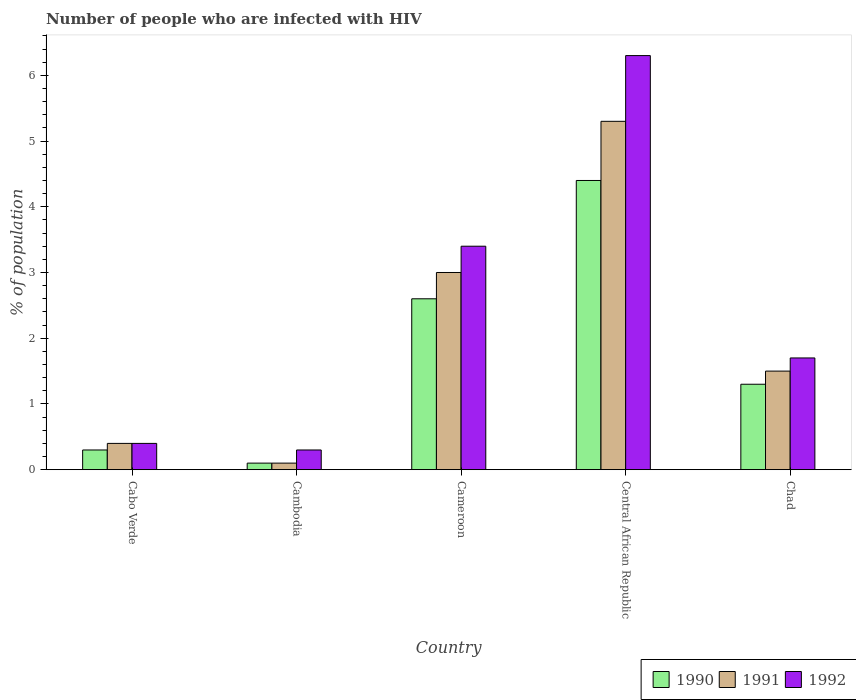How many different coloured bars are there?
Ensure brevity in your answer.  3. How many groups of bars are there?
Your answer should be very brief. 5. Are the number of bars per tick equal to the number of legend labels?
Make the answer very short. Yes. How many bars are there on the 1st tick from the right?
Offer a terse response. 3. What is the label of the 1st group of bars from the left?
Ensure brevity in your answer.  Cabo Verde. What is the percentage of HIV infected population in in 1991 in Cabo Verde?
Offer a terse response. 0.4. Across all countries, what is the maximum percentage of HIV infected population in in 1990?
Offer a very short reply. 4.4. In which country was the percentage of HIV infected population in in 1992 maximum?
Offer a terse response. Central African Republic. In which country was the percentage of HIV infected population in in 1992 minimum?
Your response must be concise. Cambodia. What is the total percentage of HIV infected population in in 1992 in the graph?
Provide a succinct answer. 12.1. What is the difference between the percentage of HIV infected population in in 1990 in Central African Republic and that in Chad?
Ensure brevity in your answer.  3.1. What is the difference between the percentage of HIV infected population in in 1992 in Cameroon and the percentage of HIV infected population in in 1991 in Cabo Verde?
Your answer should be compact. 3. What is the average percentage of HIV infected population in in 1991 per country?
Provide a short and direct response. 2.06. What is the difference between the percentage of HIV infected population in of/in 1992 and percentage of HIV infected population in of/in 1990 in Cambodia?
Your answer should be very brief. 0.2. In how many countries, is the percentage of HIV infected population in in 1991 greater than 2.6 %?
Your answer should be compact. 2. What is the ratio of the percentage of HIV infected population in in 1991 in Cameroon to that in Central African Republic?
Offer a terse response. 0.57. Is the percentage of HIV infected population in in 1990 in Cabo Verde less than that in Cambodia?
Offer a very short reply. No. Is the difference between the percentage of HIV infected population in in 1992 in Cambodia and Central African Republic greater than the difference between the percentage of HIV infected population in in 1990 in Cambodia and Central African Republic?
Keep it short and to the point. No. What is the difference between the highest and the second highest percentage of HIV infected population in in 1990?
Offer a very short reply. -1.3. What is the difference between the highest and the lowest percentage of HIV infected population in in 1990?
Ensure brevity in your answer.  4.3. In how many countries, is the percentage of HIV infected population in in 1992 greater than the average percentage of HIV infected population in in 1992 taken over all countries?
Offer a very short reply. 2. Is the sum of the percentage of HIV infected population in in 1992 in Cameroon and Central African Republic greater than the maximum percentage of HIV infected population in in 1991 across all countries?
Offer a terse response. Yes. What does the 1st bar from the left in Chad represents?
Keep it short and to the point. 1990. How many bars are there?
Offer a terse response. 15. What is the difference between two consecutive major ticks on the Y-axis?
Keep it short and to the point. 1. Does the graph contain any zero values?
Offer a terse response. No. How are the legend labels stacked?
Provide a short and direct response. Horizontal. What is the title of the graph?
Provide a short and direct response. Number of people who are infected with HIV. What is the label or title of the Y-axis?
Offer a very short reply. % of population. What is the % of population of 1992 in Cambodia?
Make the answer very short. 0.3. What is the % of population of 1990 in Cameroon?
Your answer should be compact. 2.6. What is the % of population in 1992 in Cameroon?
Provide a succinct answer. 3.4. What is the % of population of 1990 in Central African Republic?
Provide a short and direct response. 4.4. What is the % of population in 1992 in Central African Republic?
Give a very brief answer. 6.3. What is the % of population in 1990 in Chad?
Provide a short and direct response. 1.3. What is the % of population of 1991 in Chad?
Provide a short and direct response. 1.5. What is the % of population in 1992 in Chad?
Provide a short and direct response. 1.7. Across all countries, what is the maximum % of population in 1991?
Offer a very short reply. 5.3. Across all countries, what is the maximum % of population in 1992?
Make the answer very short. 6.3. Across all countries, what is the minimum % of population in 1990?
Provide a succinct answer. 0.1. Across all countries, what is the minimum % of population of 1991?
Offer a terse response. 0.1. What is the total % of population of 1990 in the graph?
Your answer should be very brief. 8.7. What is the total % of population in 1992 in the graph?
Your answer should be compact. 12.1. What is the difference between the % of population of 1991 in Cabo Verde and that in Cambodia?
Keep it short and to the point. 0.3. What is the difference between the % of population of 1992 in Cabo Verde and that in Cambodia?
Keep it short and to the point. 0.1. What is the difference between the % of population of 1990 in Cabo Verde and that in Central African Republic?
Keep it short and to the point. -4.1. What is the difference between the % of population of 1990 in Cambodia and that in Cameroon?
Your response must be concise. -2.5. What is the difference between the % of population of 1991 in Cambodia and that in Central African Republic?
Your answer should be compact. -5.2. What is the difference between the % of population of 1990 in Cambodia and that in Chad?
Your answer should be compact. -1.2. What is the difference between the % of population of 1991 in Cambodia and that in Chad?
Keep it short and to the point. -1.4. What is the difference between the % of population of 1992 in Cambodia and that in Chad?
Offer a terse response. -1.4. What is the difference between the % of population in 1990 in Cameroon and that in Chad?
Give a very brief answer. 1.3. What is the difference between the % of population in 1990 in Central African Republic and that in Chad?
Provide a short and direct response. 3.1. What is the difference between the % of population of 1991 in Central African Republic and that in Chad?
Your answer should be very brief. 3.8. What is the difference between the % of population in 1992 in Central African Republic and that in Chad?
Your answer should be very brief. 4.6. What is the difference between the % of population of 1990 in Cabo Verde and the % of population of 1991 in Cambodia?
Your answer should be compact. 0.2. What is the difference between the % of population in 1990 in Cabo Verde and the % of population in 1992 in Cambodia?
Make the answer very short. 0. What is the difference between the % of population in 1991 in Cabo Verde and the % of population in 1992 in Cambodia?
Your answer should be very brief. 0.1. What is the difference between the % of population in 1990 in Cabo Verde and the % of population in 1991 in Cameroon?
Provide a succinct answer. -2.7. What is the difference between the % of population of 1991 in Cabo Verde and the % of population of 1992 in Cameroon?
Offer a terse response. -3. What is the difference between the % of population of 1990 in Cabo Verde and the % of population of 1991 in Central African Republic?
Provide a succinct answer. -5. What is the difference between the % of population of 1990 in Cabo Verde and the % of population of 1992 in Central African Republic?
Your answer should be very brief. -6. What is the difference between the % of population of 1991 in Cabo Verde and the % of population of 1992 in Central African Republic?
Ensure brevity in your answer.  -5.9. What is the difference between the % of population in 1990 in Cabo Verde and the % of population in 1992 in Chad?
Your response must be concise. -1.4. What is the difference between the % of population of 1990 in Cambodia and the % of population of 1991 in Cameroon?
Your answer should be very brief. -2.9. What is the difference between the % of population in 1990 in Cambodia and the % of population in 1992 in Cameroon?
Ensure brevity in your answer.  -3.3. What is the difference between the % of population in 1990 in Cambodia and the % of population in 1992 in Central African Republic?
Make the answer very short. -6.2. What is the difference between the % of population in 1991 in Cambodia and the % of population in 1992 in Central African Republic?
Your answer should be compact. -6.2. What is the difference between the % of population of 1990 in Cambodia and the % of population of 1991 in Chad?
Give a very brief answer. -1.4. What is the difference between the % of population in 1990 in Cambodia and the % of population in 1992 in Chad?
Offer a terse response. -1.6. What is the difference between the % of population in 1991 in Cambodia and the % of population in 1992 in Chad?
Offer a terse response. -1.6. What is the difference between the % of population in 1990 in Cameroon and the % of population in 1991 in Chad?
Ensure brevity in your answer.  1.1. What is the difference between the % of population in 1990 in Cameroon and the % of population in 1992 in Chad?
Make the answer very short. 0.9. What is the difference between the % of population in 1991 in Cameroon and the % of population in 1992 in Chad?
Offer a very short reply. 1.3. What is the difference between the % of population in 1990 in Central African Republic and the % of population in 1992 in Chad?
Ensure brevity in your answer.  2.7. What is the difference between the % of population in 1991 in Central African Republic and the % of population in 1992 in Chad?
Keep it short and to the point. 3.6. What is the average % of population of 1990 per country?
Provide a succinct answer. 1.74. What is the average % of population of 1991 per country?
Give a very brief answer. 2.06. What is the average % of population of 1992 per country?
Offer a very short reply. 2.42. What is the difference between the % of population of 1990 and % of population of 1991 in Cabo Verde?
Offer a terse response. -0.1. What is the difference between the % of population of 1991 and % of population of 1992 in Cambodia?
Your answer should be compact. -0.2. What is the difference between the % of population of 1990 and % of population of 1991 in Cameroon?
Ensure brevity in your answer.  -0.4. What is the difference between the % of population in 1991 and % of population in 1992 in Cameroon?
Provide a short and direct response. -0.4. What is the difference between the % of population in 1990 and % of population in 1992 in Central African Republic?
Provide a short and direct response. -1.9. What is the difference between the % of population of 1991 and % of population of 1992 in Central African Republic?
Provide a succinct answer. -1. What is the difference between the % of population of 1990 and % of population of 1991 in Chad?
Ensure brevity in your answer.  -0.2. What is the difference between the % of population in 1991 and % of population in 1992 in Chad?
Provide a succinct answer. -0.2. What is the ratio of the % of population in 1990 in Cabo Verde to that in Cambodia?
Provide a succinct answer. 3. What is the ratio of the % of population in 1991 in Cabo Verde to that in Cambodia?
Give a very brief answer. 4. What is the ratio of the % of population of 1990 in Cabo Verde to that in Cameroon?
Provide a succinct answer. 0.12. What is the ratio of the % of population of 1991 in Cabo Verde to that in Cameroon?
Ensure brevity in your answer.  0.13. What is the ratio of the % of population of 1992 in Cabo Verde to that in Cameroon?
Offer a very short reply. 0.12. What is the ratio of the % of population of 1990 in Cabo Verde to that in Central African Republic?
Offer a terse response. 0.07. What is the ratio of the % of population in 1991 in Cabo Verde to that in Central African Republic?
Give a very brief answer. 0.08. What is the ratio of the % of population of 1992 in Cabo Verde to that in Central African Republic?
Provide a succinct answer. 0.06. What is the ratio of the % of population of 1990 in Cabo Verde to that in Chad?
Your response must be concise. 0.23. What is the ratio of the % of population of 1991 in Cabo Verde to that in Chad?
Keep it short and to the point. 0.27. What is the ratio of the % of population in 1992 in Cabo Verde to that in Chad?
Offer a terse response. 0.24. What is the ratio of the % of population in 1990 in Cambodia to that in Cameroon?
Give a very brief answer. 0.04. What is the ratio of the % of population in 1991 in Cambodia to that in Cameroon?
Provide a short and direct response. 0.03. What is the ratio of the % of population in 1992 in Cambodia to that in Cameroon?
Offer a very short reply. 0.09. What is the ratio of the % of population of 1990 in Cambodia to that in Central African Republic?
Give a very brief answer. 0.02. What is the ratio of the % of population of 1991 in Cambodia to that in Central African Republic?
Offer a very short reply. 0.02. What is the ratio of the % of population of 1992 in Cambodia to that in Central African Republic?
Your response must be concise. 0.05. What is the ratio of the % of population of 1990 in Cambodia to that in Chad?
Your response must be concise. 0.08. What is the ratio of the % of population in 1991 in Cambodia to that in Chad?
Make the answer very short. 0.07. What is the ratio of the % of population in 1992 in Cambodia to that in Chad?
Make the answer very short. 0.18. What is the ratio of the % of population in 1990 in Cameroon to that in Central African Republic?
Your response must be concise. 0.59. What is the ratio of the % of population of 1991 in Cameroon to that in Central African Republic?
Give a very brief answer. 0.57. What is the ratio of the % of population of 1992 in Cameroon to that in Central African Republic?
Ensure brevity in your answer.  0.54. What is the ratio of the % of population in 1990 in Cameroon to that in Chad?
Offer a terse response. 2. What is the ratio of the % of population of 1991 in Cameroon to that in Chad?
Provide a short and direct response. 2. What is the ratio of the % of population of 1990 in Central African Republic to that in Chad?
Offer a very short reply. 3.38. What is the ratio of the % of population in 1991 in Central African Republic to that in Chad?
Your response must be concise. 3.53. What is the ratio of the % of population of 1992 in Central African Republic to that in Chad?
Provide a succinct answer. 3.71. What is the difference between the highest and the second highest % of population in 1990?
Ensure brevity in your answer.  1.8. What is the difference between the highest and the lowest % of population of 1990?
Give a very brief answer. 4.3. What is the difference between the highest and the lowest % of population of 1991?
Your response must be concise. 5.2. What is the difference between the highest and the lowest % of population in 1992?
Your response must be concise. 6. 